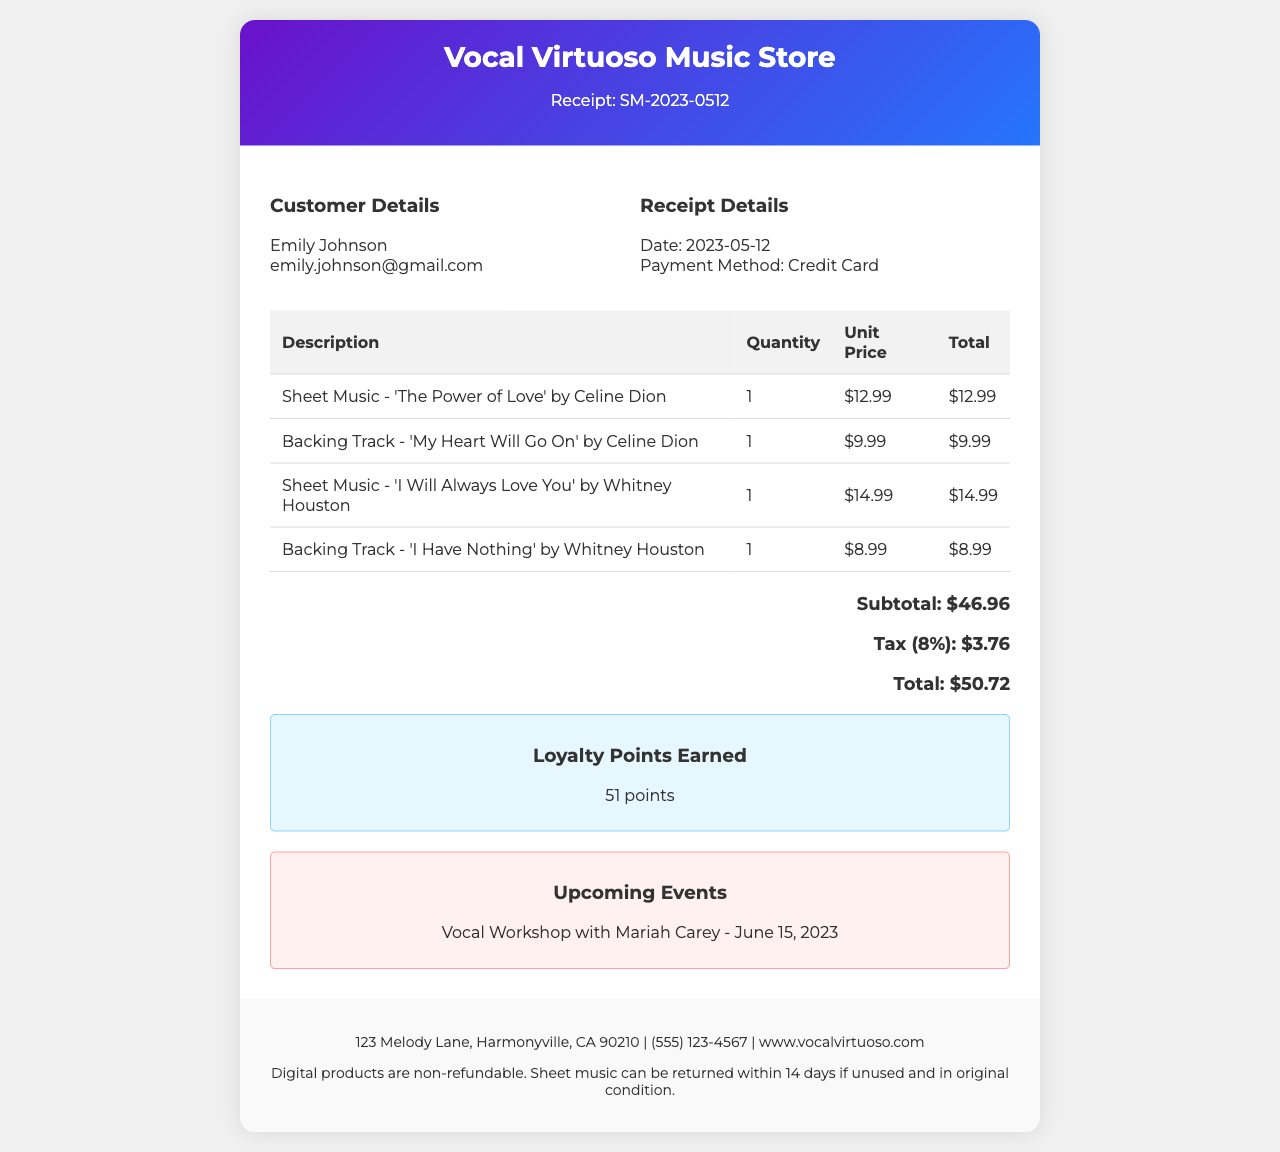What is the receipt number? The receipt number is clearly stated at the top of the document, which is SM-2023-0512.
Answer: SM-2023-0512 What is the date of the transaction? The date is displayed prominently in the receipt, which is 2023-05-12.
Answer: 2023-05-12 Who is the customer? The customer's name is mentioned in the document, which is Emily Johnson.
Answer: Emily Johnson How many items are listed in the receipt? The items are enumerated in the table, showing a total of four items.
Answer: 4 What is the total amount charged? The total is calculated at the bottom of the receipt, which sums up to $50.72.
Answer: $50.72 What payment method was used? The payment method is specified under the receipt details, which is Credit Card.
Answer: Credit Card What is the tax amount? The tax amount is calculated and displayed in the total section, which is $3.76.
Answer: $3.76 What is the store address? The store address is provided in the footer of the receipt, which is 123 Melody Lane, Harmonyville, CA 90210.
Answer: 123 Melody Lane, Harmonyville, CA 90210 What is the return policy for sheet music? The return policy is outlined in the footer; for sheet music, it states it can be returned within 14 days if unused and in original condition.
Answer: Sheet music can be returned within 14 days if unused and in original condition 